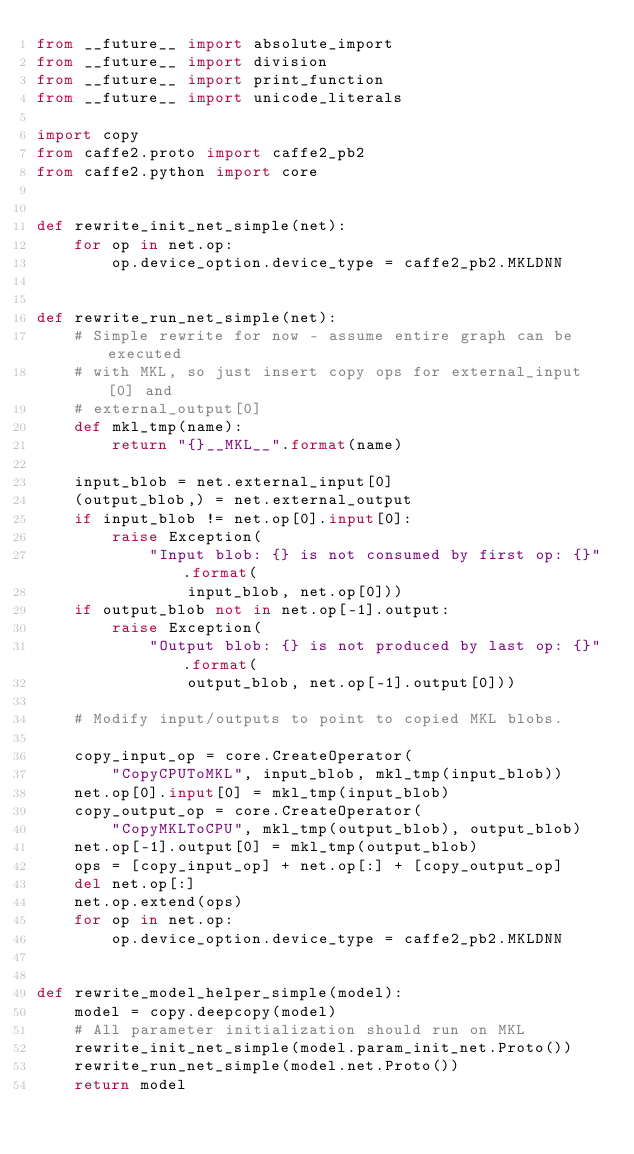Convert code to text. <code><loc_0><loc_0><loc_500><loc_500><_Python_>from __future__ import absolute_import
from __future__ import division
from __future__ import print_function
from __future__ import unicode_literals

import copy
from caffe2.proto import caffe2_pb2
from caffe2.python import core


def rewrite_init_net_simple(net):
    for op in net.op:
        op.device_option.device_type = caffe2_pb2.MKLDNN


def rewrite_run_net_simple(net):
    # Simple rewrite for now - assume entire graph can be executed
    # with MKL, so just insert copy ops for external_input[0] and
    # external_output[0]
    def mkl_tmp(name):
        return "{}__MKL__".format(name)

    input_blob = net.external_input[0]
    (output_blob,) = net.external_output
    if input_blob != net.op[0].input[0]:
        raise Exception(
            "Input blob: {} is not consumed by first op: {}".format(
                input_blob, net.op[0]))
    if output_blob not in net.op[-1].output:
        raise Exception(
            "Output blob: {} is not produced by last op: {}".format(
                output_blob, net.op[-1].output[0]))

    # Modify input/outputs to point to copied MKL blobs.

    copy_input_op = core.CreateOperator(
        "CopyCPUToMKL", input_blob, mkl_tmp(input_blob))
    net.op[0].input[0] = mkl_tmp(input_blob)
    copy_output_op = core.CreateOperator(
        "CopyMKLToCPU", mkl_tmp(output_blob), output_blob)
    net.op[-1].output[0] = mkl_tmp(output_blob)
    ops = [copy_input_op] + net.op[:] + [copy_output_op]
    del net.op[:]
    net.op.extend(ops)
    for op in net.op:
        op.device_option.device_type = caffe2_pb2.MKLDNN


def rewrite_model_helper_simple(model):
    model = copy.deepcopy(model)
    # All parameter initialization should run on MKL
    rewrite_init_net_simple(model.param_init_net.Proto())
    rewrite_run_net_simple(model.net.Proto())
    return model
</code> 